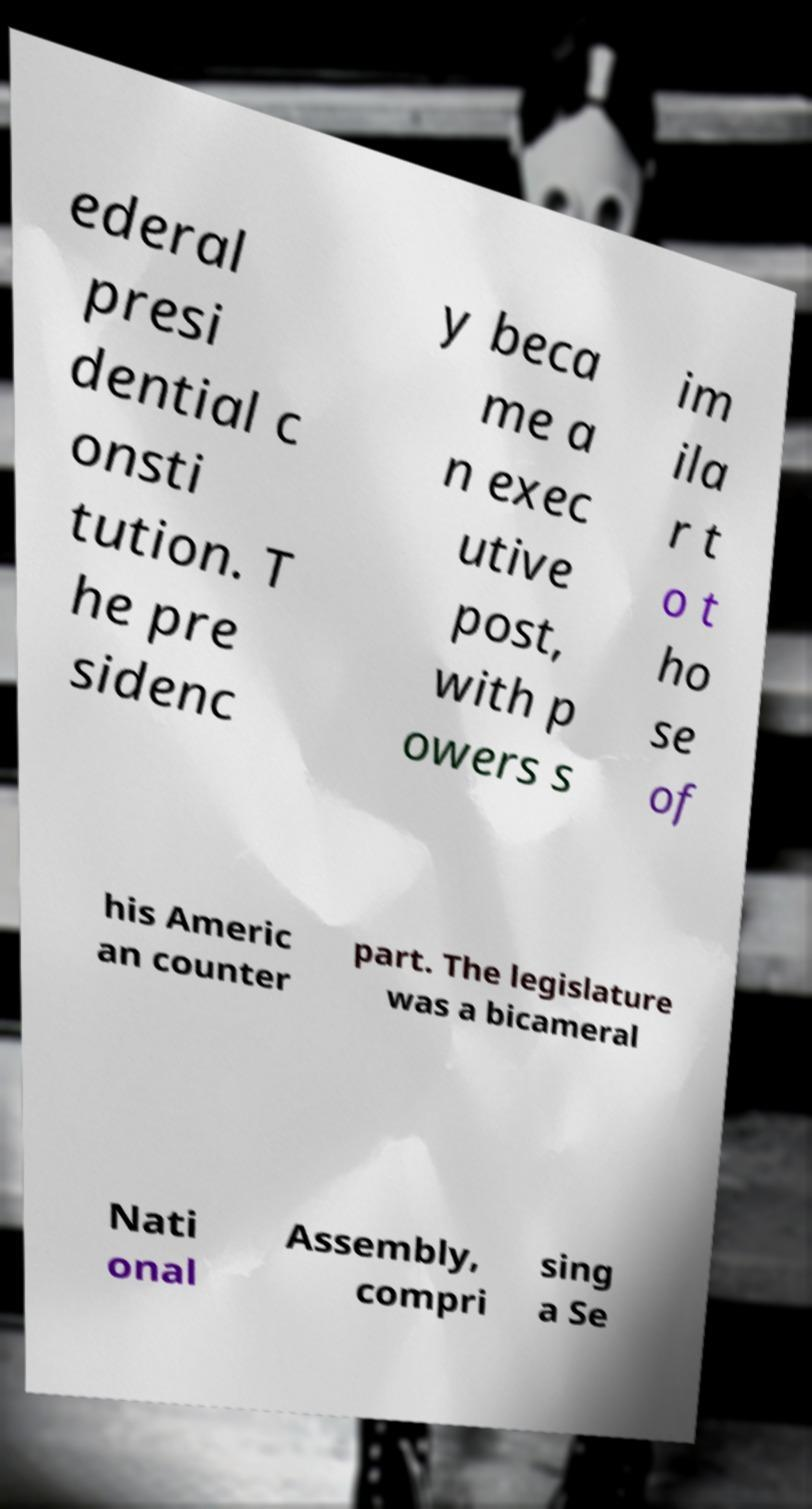Could you assist in decoding the text presented in this image and type it out clearly? ederal presi dential c onsti tution. T he pre sidenc y beca me a n exec utive post, with p owers s im ila r t o t ho se of his Americ an counter part. The legislature was a bicameral Nati onal Assembly, compri sing a Se 